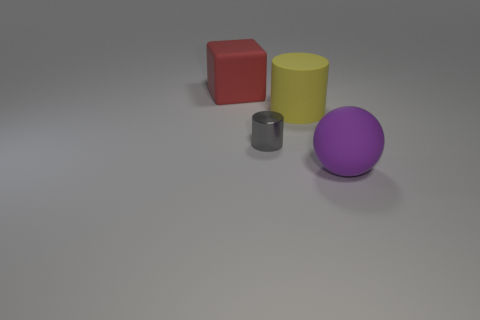Is there a large purple matte object right of the cylinder that is in front of the yellow matte cylinder?
Offer a terse response. Yes. What is the color of the matte sphere that is the same size as the yellow rubber cylinder?
Offer a terse response. Purple. Are there the same number of red things behind the big block and large yellow cylinders in front of the gray cylinder?
Your response must be concise. Yes. There is a object that is in front of the cylinder that is on the left side of the large yellow matte thing; what is it made of?
Offer a terse response. Rubber. What number of things are either small purple things or matte things?
Keep it short and to the point. 3. Is the number of large red things less than the number of blue metal objects?
Your answer should be compact. No. The gray cylinder has what size?
Your answer should be compact. Small. What shape is the small gray thing?
Offer a terse response. Cylinder. What is the size of the other shiny thing that is the same shape as the yellow object?
Offer a very short reply. Small. Is there anything else that is made of the same material as the small gray object?
Your answer should be very brief. No. 